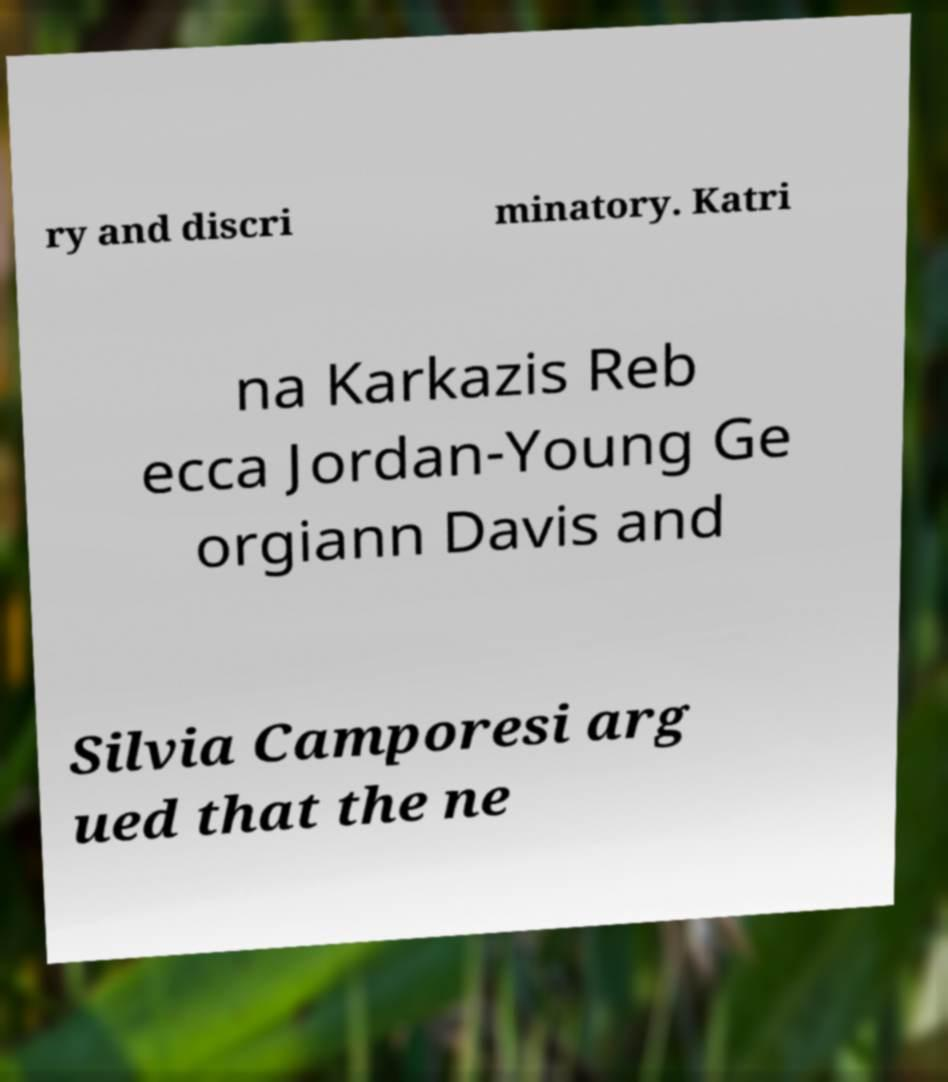There's text embedded in this image that I need extracted. Can you transcribe it verbatim? ry and discri minatory. Katri na Karkazis Reb ecca Jordan-Young Ge orgiann Davis and Silvia Camporesi arg ued that the ne 